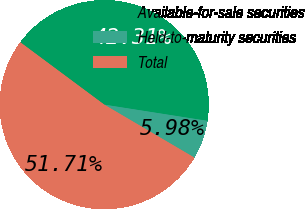Convert chart to OTSL. <chart><loc_0><loc_0><loc_500><loc_500><pie_chart><fcel>Available-for-sale securities<fcel>Held-to-maturity securities<fcel>Total<nl><fcel>42.31%<fcel>5.98%<fcel>51.71%<nl></chart> 